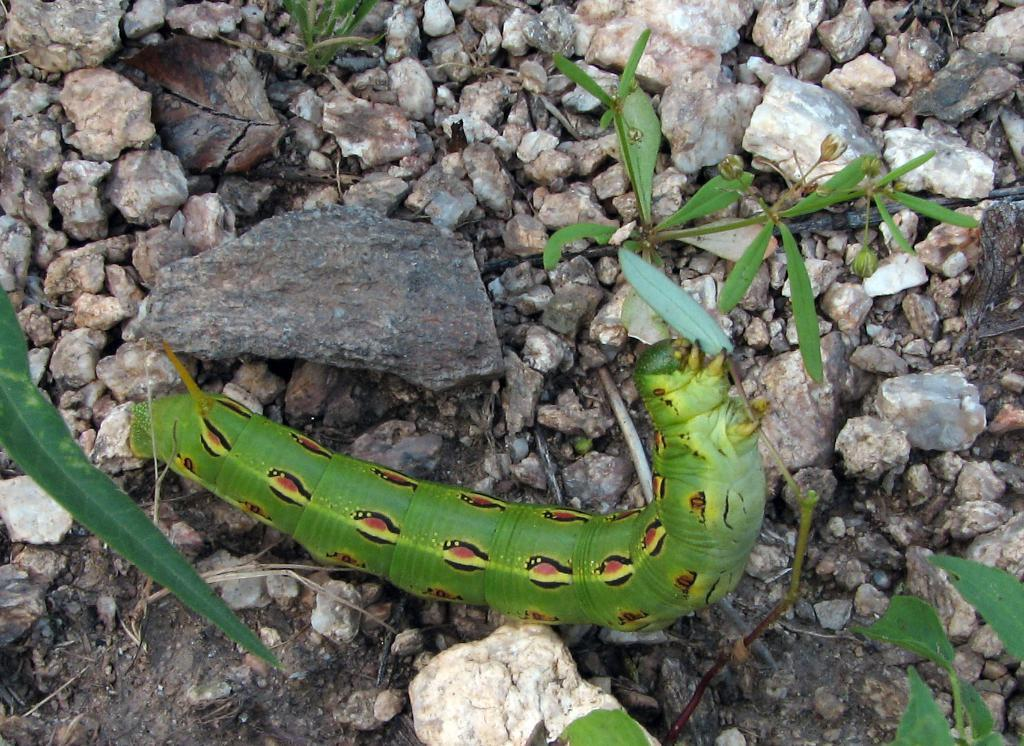What type of insect is in the image? There is a green color insect in the image. Where is the insect located? The insect is on the ground. What else can be seen on the ground in the image? There are small stones in the image. What type of vegetation is present in the image? There are green leaves in the image. What is the account number of the vein in the image? There is no account number or vein present in the image. The image features a green color insect, small stones, and green leaves. 